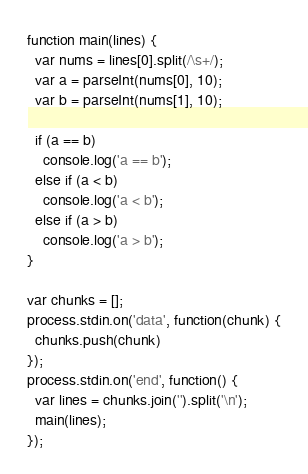<code> <loc_0><loc_0><loc_500><loc_500><_JavaScript_>function main(lines) {
  var nums = lines[0].split(/\s+/);
  var a = parseInt(nums[0], 10);
  var b = parseInt(nums[1], 10);

  if (a == b)
    console.log('a == b');
  else if (a < b)
    console.log('a < b');
  else if (a > b)
    console.log('a > b');
}

var chunks = [];
process.stdin.on('data', function(chunk) {
  chunks.push(chunk)
});
process.stdin.on('end', function() {
  var lines = chunks.join('').split('\n');
  main(lines);
});</code> 